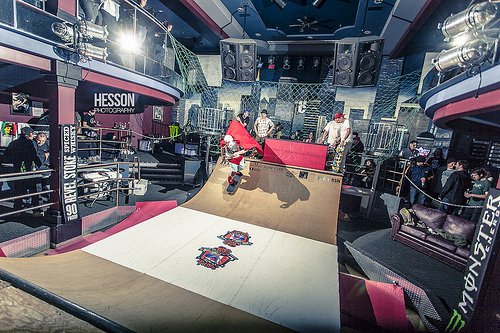<image>
Is there a shadow on the ramp? Yes. Looking at the image, I can see the shadow is positioned on top of the ramp, with the ramp providing support. 